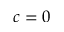Convert formula to latex. <formula><loc_0><loc_0><loc_500><loc_500>c = 0</formula> 